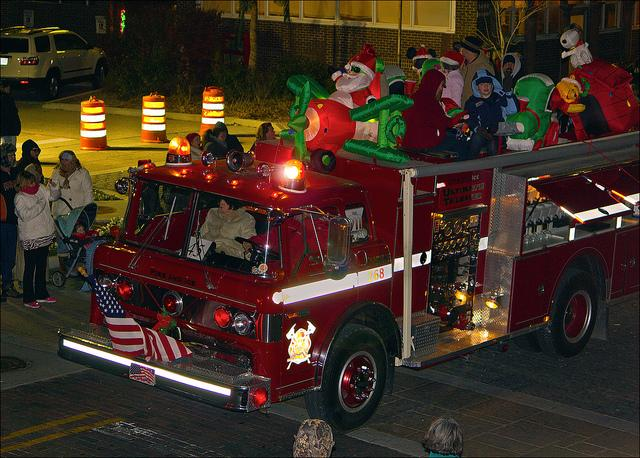What sort of Holiday parade is being feted here? christmas 